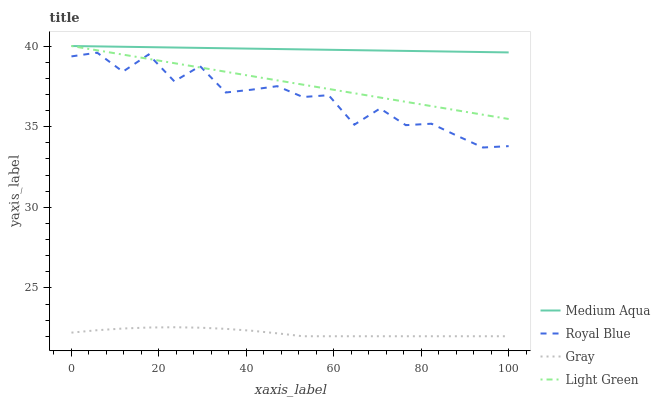Does Gray have the minimum area under the curve?
Answer yes or no. Yes. Does Medium Aqua have the maximum area under the curve?
Answer yes or no. Yes. Does Light Green have the minimum area under the curve?
Answer yes or no. No. Does Light Green have the maximum area under the curve?
Answer yes or no. No. Is Light Green the smoothest?
Answer yes or no. Yes. Is Royal Blue the roughest?
Answer yes or no. Yes. Is Medium Aqua the smoothest?
Answer yes or no. No. Is Medium Aqua the roughest?
Answer yes or no. No. Does Light Green have the lowest value?
Answer yes or no. No. Does Gray have the highest value?
Answer yes or no. No. Is Royal Blue less than Medium Aqua?
Answer yes or no. Yes. Is Medium Aqua greater than Gray?
Answer yes or no. Yes. Does Royal Blue intersect Medium Aqua?
Answer yes or no. No. 